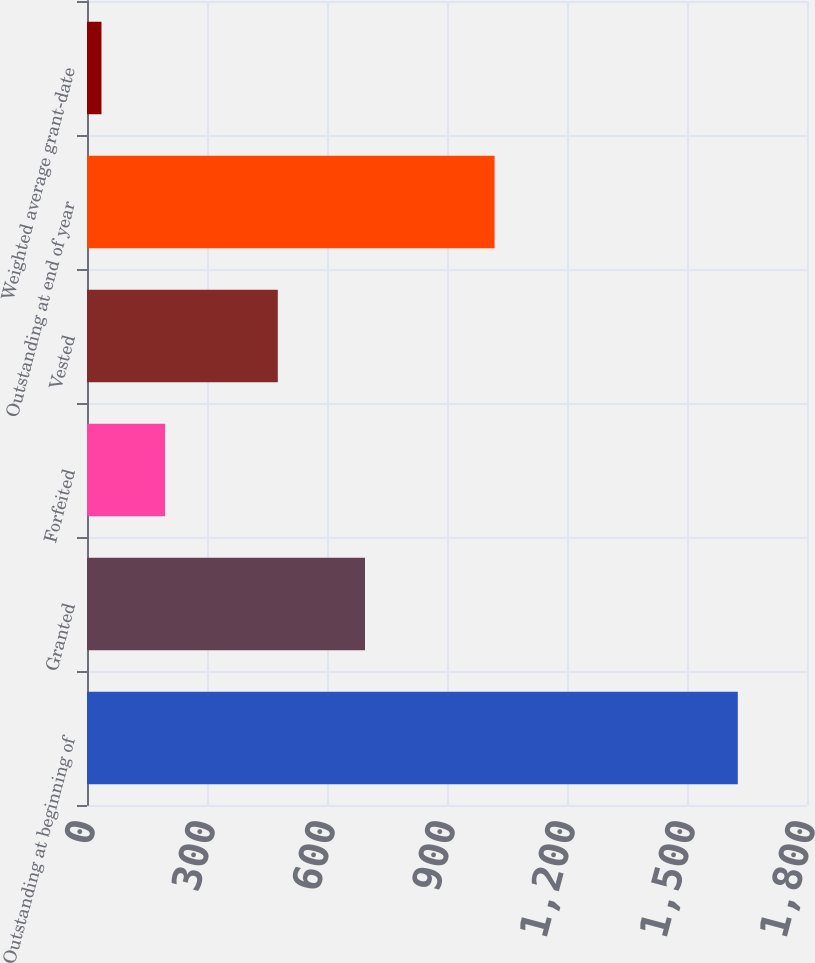<chart> <loc_0><loc_0><loc_500><loc_500><bar_chart><fcel>Outstanding at beginning of<fcel>Granted<fcel>Forfeited<fcel>Vested<fcel>Outstanding at end of year<fcel>Weighted average grant-date<nl><fcel>1627<fcel>695<fcel>195.23<fcel>477<fcel>1019<fcel>36.14<nl></chart> 